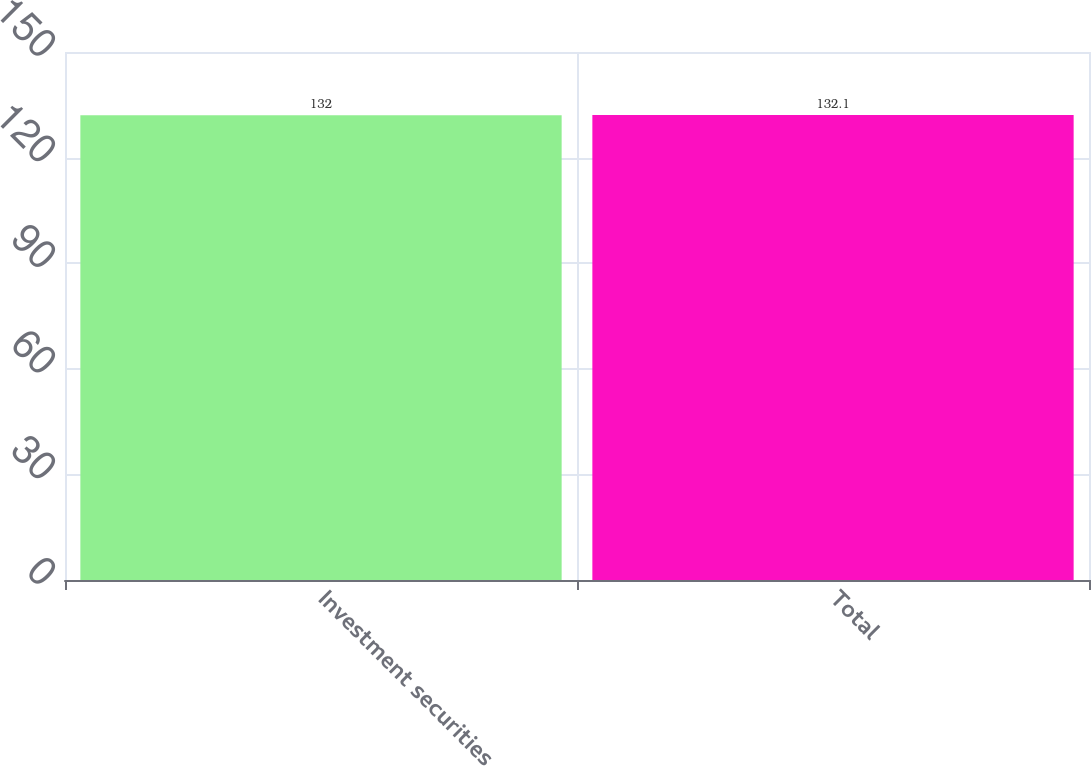Convert chart to OTSL. <chart><loc_0><loc_0><loc_500><loc_500><bar_chart><fcel>Investment securities<fcel>Total<nl><fcel>132<fcel>132.1<nl></chart> 